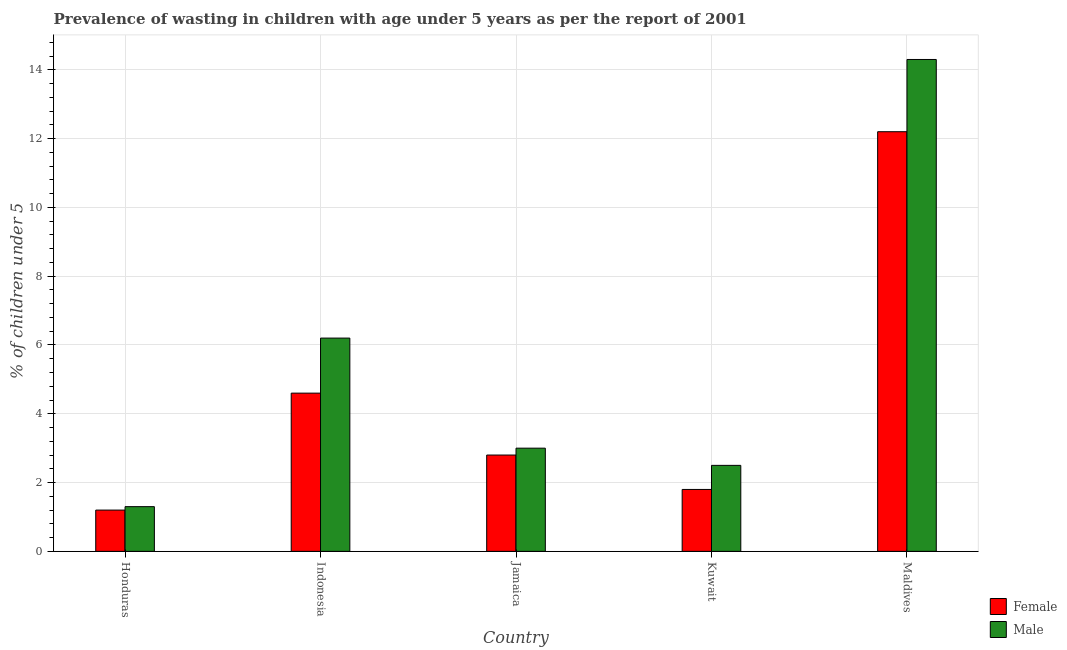How many groups of bars are there?
Provide a succinct answer. 5. Are the number of bars per tick equal to the number of legend labels?
Ensure brevity in your answer.  Yes. Are the number of bars on each tick of the X-axis equal?
Offer a terse response. Yes. How many bars are there on the 2nd tick from the left?
Your answer should be very brief. 2. What is the label of the 1st group of bars from the left?
Your answer should be compact. Honduras. What is the percentage of undernourished male children in Jamaica?
Your response must be concise. 3. Across all countries, what is the maximum percentage of undernourished male children?
Keep it short and to the point. 14.3. Across all countries, what is the minimum percentage of undernourished male children?
Provide a short and direct response. 1.3. In which country was the percentage of undernourished female children maximum?
Keep it short and to the point. Maldives. In which country was the percentage of undernourished male children minimum?
Offer a very short reply. Honduras. What is the total percentage of undernourished female children in the graph?
Provide a succinct answer. 22.6. What is the difference between the percentage of undernourished male children in Indonesia and that in Maldives?
Offer a very short reply. -8.1. What is the difference between the percentage of undernourished male children in Indonesia and the percentage of undernourished female children in Honduras?
Make the answer very short. 5. What is the average percentage of undernourished female children per country?
Your response must be concise. 4.52. What is the difference between the percentage of undernourished female children and percentage of undernourished male children in Indonesia?
Provide a succinct answer. -1.6. What is the ratio of the percentage of undernourished female children in Honduras to that in Jamaica?
Ensure brevity in your answer.  0.43. What is the difference between the highest and the second highest percentage of undernourished male children?
Give a very brief answer. 8.1. What is the difference between the highest and the lowest percentage of undernourished male children?
Provide a short and direct response. 13. Is the sum of the percentage of undernourished male children in Honduras and Indonesia greater than the maximum percentage of undernourished female children across all countries?
Your response must be concise. No. What does the 2nd bar from the left in Indonesia represents?
Offer a very short reply. Male. How many bars are there?
Make the answer very short. 10. Are all the bars in the graph horizontal?
Your answer should be very brief. No. What is the difference between two consecutive major ticks on the Y-axis?
Your answer should be compact. 2. Does the graph contain grids?
Your answer should be very brief. Yes. How are the legend labels stacked?
Provide a short and direct response. Vertical. What is the title of the graph?
Ensure brevity in your answer.  Prevalence of wasting in children with age under 5 years as per the report of 2001. What is the label or title of the Y-axis?
Make the answer very short.  % of children under 5. What is the  % of children under 5 in Female in Honduras?
Your response must be concise. 1.2. What is the  % of children under 5 in Male in Honduras?
Provide a succinct answer. 1.3. What is the  % of children under 5 in Female in Indonesia?
Provide a short and direct response. 4.6. What is the  % of children under 5 in Male in Indonesia?
Make the answer very short. 6.2. What is the  % of children under 5 of Female in Jamaica?
Make the answer very short. 2.8. What is the  % of children under 5 in Female in Kuwait?
Provide a short and direct response. 1.8. What is the  % of children under 5 in Male in Kuwait?
Make the answer very short. 2.5. What is the  % of children under 5 of Female in Maldives?
Offer a terse response. 12.2. What is the  % of children under 5 of Male in Maldives?
Make the answer very short. 14.3. Across all countries, what is the maximum  % of children under 5 of Female?
Your response must be concise. 12.2. Across all countries, what is the maximum  % of children under 5 in Male?
Give a very brief answer. 14.3. Across all countries, what is the minimum  % of children under 5 in Female?
Give a very brief answer. 1.2. Across all countries, what is the minimum  % of children under 5 in Male?
Provide a short and direct response. 1.3. What is the total  % of children under 5 in Female in the graph?
Give a very brief answer. 22.6. What is the total  % of children under 5 of Male in the graph?
Give a very brief answer. 27.3. What is the difference between the  % of children under 5 of Female in Honduras and that in Indonesia?
Make the answer very short. -3.4. What is the difference between the  % of children under 5 of Male in Honduras and that in Indonesia?
Your response must be concise. -4.9. What is the difference between the  % of children under 5 in Female in Honduras and that in Jamaica?
Your answer should be very brief. -1.6. What is the difference between the  % of children under 5 of Male in Honduras and that in Jamaica?
Offer a very short reply. -1.7. What is the difference between the  % of children under 5 of Female in Honduras and that in Maldives?
Offer a very short reply. -11. What is the difference between the  % of children under 5 in Female in Indonesia and that in Maldives?
Your answer should be very brief. -7.6. What is the difference between the  % of children under 5 of Male in Indonesia and that in Maldives?
Your answer should be compact. -8.1. What is the difference between the  % of children under 5 of Female in Jamaica and that in Kuwait?
Make the answer very short. 1. What is the difference between the  % of children under 5 of Male in Jamaica and that in Kuwait?
Give a very brief answer. 0.5. What is the difference between the  % of children under 5 of Male in Jamaica and that in Maldives?
Give a very brief answer. -11.3. What is the difference between the  % of children under 5 in Male in Kuwait and that in Maldives?
Offer a terse response. -11.8. What is the difference between the  % of children under 5 of Female in Honduras and the  % of children under 5 of Male in Indonesia?
Your answer should be compact. -5. What is the difference between the  % of children under 5 in Female in Indonesia and the  % of children under 5 in Male in Jamaica?
Your answer should be compact. 1.6. What is the difference between the  % of children under 5 in Female in Indonesia and the  % of children under 5 in Male in Kuwait?
Ensure brevity in your answer.  2.1. What is the average  % of children under 5 in Female per country?
Keep it short and to the point. 4.52. What is the average  % of children under 5 in Male per country?
Offer a terse response. 5.46. What is the difference between the  % of children under 5 in Female and  % of children under 5 in Male in Jamaica?
Provide a succinct answer. -0.2. What is the difference between the  % of children under 5 of Female and  % of children under 5 of Male in Maldives?
Provide a succinct answer. -2.1. What is the ratio of the  % of children under 5 of Female in Honduras to that in Indonesia?
Offer a very short reply. 0.26. What is the ratio of the  % of children under 5 in Male in Honduras to that in Indonesia?
Ensure brevity in your answer.  0.21. What is the ratio of the  % of children under 5 in Female in Honduras to that in Jamaica?
Make the answer very short. 0.43. What is the ratio of the  % of children under 5 in Male in Honduras to that in Jamaica?
Provide a succinct answer. 0.43. What is the ratio of the  % of children under 5 of Female in Honduras to that in Kuwait?
Your response must be concise. 0.67. What is the ratio of the  % of children under 5 of Male in Honduras to that in Kuwait?
Your response must be concise. 0.52. What is the ratio of the  % of children under 5 in Female in Honduras to that in Maldives?
Make the answer very short. 0.1. What is the ratio of the  % of children under 5 of Male in Honduras to that in Maldives?
Offer a terse response. 0.09. What is the ratio of the  % of children under 5 of Female in Indonesia to that in Jamaica?
Keep it short and to the point. 1.64. What is the ratio of the  % of children under 5 in Male in Indonesia to that in Jamaica?
Keep it short and to the point. 2.07. What is the ratio of the  % of children under 5 of Female in Indonesia to that in Kuwait?
Your answer should be very brief. 2.56. What is the ratio of the  % of children under 5 in Male in Indonesia to that in Kuwait?
Offer a very short reply. 2.48. What is the ratio of the  % of children under 5 in Female in Indonesia to that in Maldives?
Keep it short and to the point. 0.38. What is the ratio of the  % of children under 5 in Male in Indonesia to that in Maldives?
Your answer should be compact. 0.43. What is the ratio of the  % of children under 5 in Female in Jamaica to that in Kuwait?
Provide a short and direct response. 1.56. What is the ratio of the  % of children under 5 of Male in Jamaica to that in Kuwait?
Ensure brevity in your answer.  1.2. What is the ratio of the  % of children under 5 of Female in Jamaica to that in Maldives?
Offer a terse response. 0.23. What is the ratio of the  % of children under 5 in Male in Jamaica to that in Maldives?
Your answer should be very brief. 0.21. What is the ratio of the  % of children under 5 in Female in Kuwait to that in Maldives?
Keep it short and to the point. 0.15. What is the ratio of the  % of children under 5 in Male in Kuwait to that in Maldives?
Ensure brevity in your answer.  0.17. What is the difference between the highest and the second highest  % of children under 5 in Male?
Your response must be concise. 8.1. What is the difference between the highest and the lowest  % of children under 5 in Female?
Provide a short and direct response. 11. What is the difference between the highest and the lowest  % of children under 5 in Male?
Offer a very short reply. 13. 